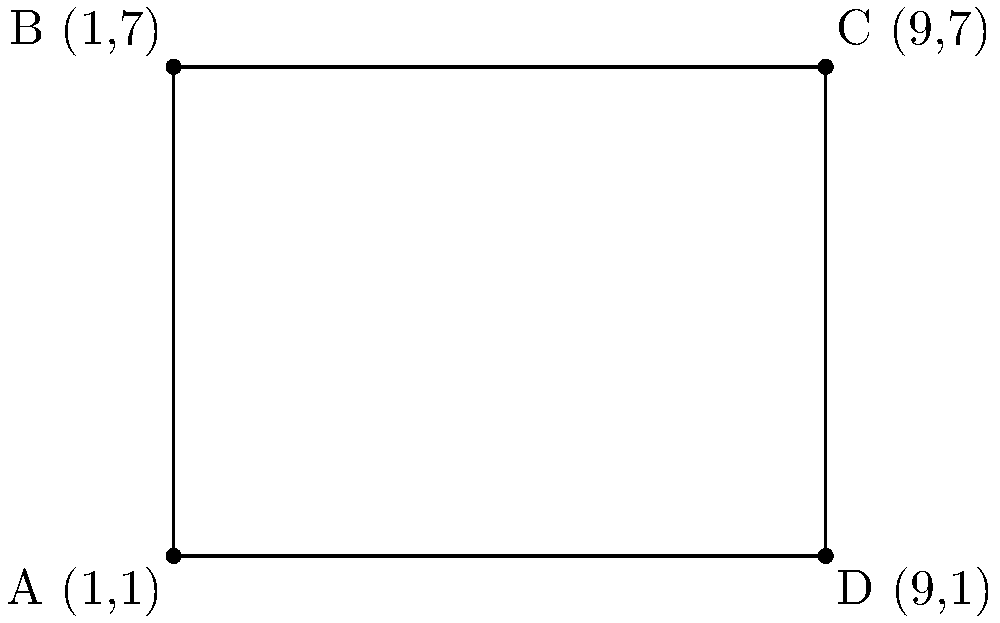A classic Western film set is represented by a rectangular area on a coordinate plane. The corners of the set are located at points A(1,1), B(1,7), C(9,7), and D(9,1). Calculate the perimeter of this film set. To calculate the perimeter of the rectangle representing the Western film set, we need to follow these steps:

1. Calculate the length of the rectangle:
   The length is the distance between points A and D (or B and C).
   Length = $|x_D - x_A| = |9 - 1| = 8$ units

2. Calculate the width of the rectangle:
   The width is the distance between points A and B (or D and C).
   Width = $|y_B - y_A| = |7 - 1| = 6$ units

3. Apply the formula for the perimeter of a rectangle:
   Perimeter = $2(length + width)$
   Perimeter = $2(8 + 6)$
   Perimeter = $2(14)$
   Perimeter = $28$ units

Therefore, the perimeter of the Western film set is 28 units.
Answer: 28 units 